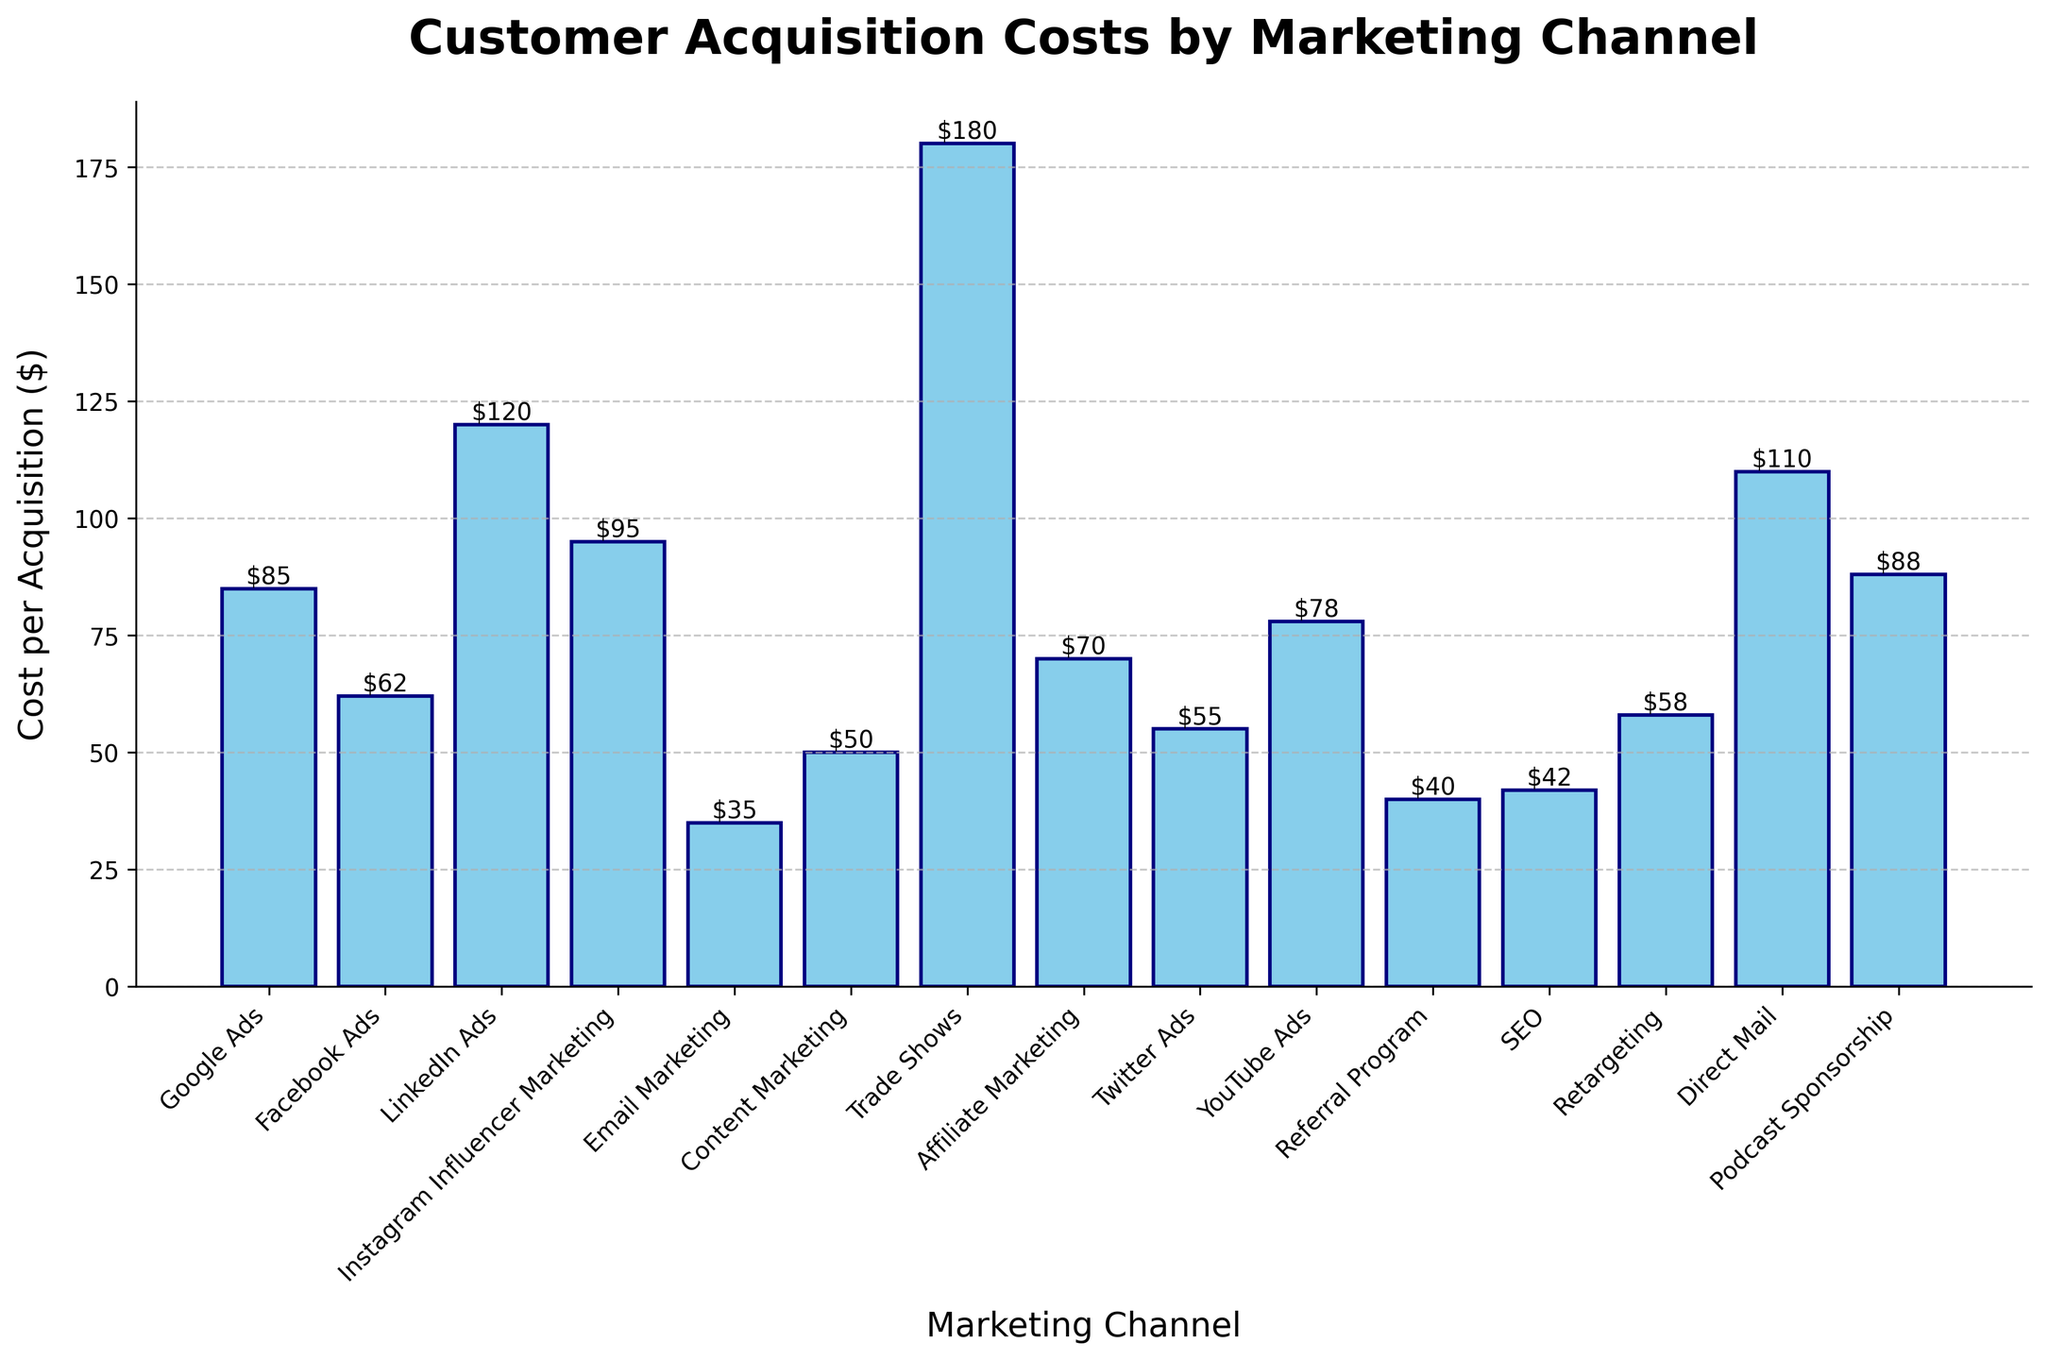Which marketing channel has the highest customer acquisition cost? By looking at the heights of the bars in the chart, the highest bar represents the channel with the highest acquisition cost. The Trade Shows channel has the highest bar.
Answer: Trade Shows What is the difference in acquisition cost between LinkedIn Ads and Facebook Ads? First, locate the bars for LinkedIn Ads and Facebook Ads. LinkedIn Ads has a height of $120, and Facebook Ads has a height of $62. The difference is $120 - $62.
Answer: $58 Which two marketing channels have acquisition costs that are equal to or less than $50? Look at the bars with heights equal to or less than $50. Email Marketing ($35) and Content Marketing ($50) meet this criterion.
Answer: Email Marketing and Content Marketing What's the average acquisition cost of Google Ads, Facebook Ads, Twitter Ads, and YouTube Ads? Add the costs of Google Ads ($85), Facebook Ads ($62), Twitter Ads ($55), and YouTube Ads ($78). Sum is $85 + $62 + $55 + $78 = $280. There are 4 channels, so the average is $280 / 4.
Answer: $70 Which channel has a lower acquisition cost: Instagram Influencer Marketing or Podcast Sponsorship? Locate the bars for Instagram Influencer Marketing ($95) and Podcast Sponsorship ($88). Compare their heights.
Answer: Podcast Sponsorship What is the combined acquisition cost of the three least expensive channels? The three least expensive channels are Email Marketing ($35), Referral Program ($40), and SEO ($42). Sum their costs: $35 + $40 + $42.
Answer: $117 How many channels have acquisition costs greater than $100? Count the bars with heights greater than $100. LinkedIn Ads ($120), Trade Shows ($180), Direct Mail ($110), and Podcast Sponsorship ($88) meet this criterion. There are 3 channels.
Answer: 3 Which channel has an intermediate acquisition cost between Google Ads and YouTube Ads? Google Ads has a cost of $85 and YouTube Ads has $78. The intermediate value falls between these two. Twitter Ads has a cost of $55 which is intermediate between Google Ads and YouTube Ads.
Answer: Twitter Ads If the acquisition cost for Direct Mail is reduced by 20%, what would be the new cost? Direct Mail's original cost is $110. Calculate 20% of $110, which is $110 * 0.2 = $22. Subtract this from the original cost: $110 - $22.
Answer: $88 